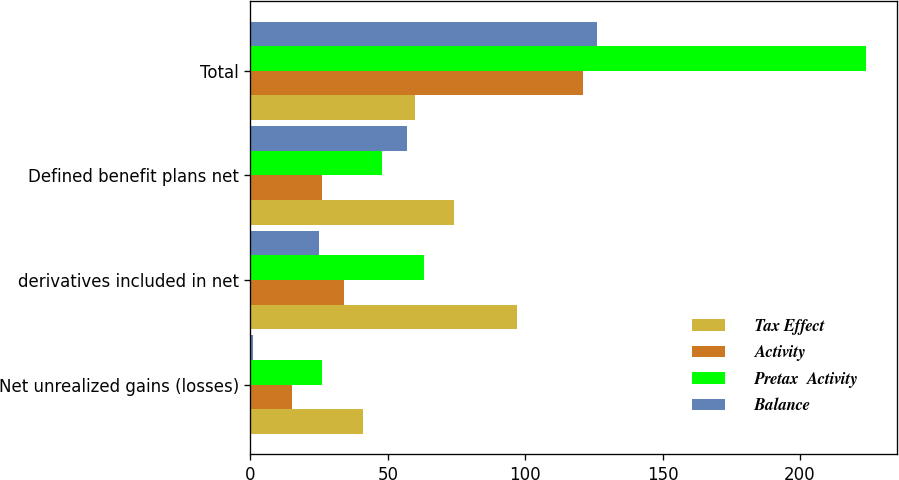<chart> <loc_0><loc_0><loc_500><loc_500><stacked_bar_chart><ecel><fcel>Net unrealized gains (losses)<fcel>derivatives included in net<fcel>Defined benefit plans net<fcel>Total<nl><fcel>Tax Effect<fcel>41<fcel>97<fcel>74<fcel>60<nl><fcel>Activity<fcel>15<fcel>34<fcel>26<fcel>121<nl><fcel>Pretax  Activity<fcel>26<fcel>63<fcel>48<fcel>224<nl><fcel>Balance<fcel>1<fcel>25<fcel>57<fcel>126<nl></chart> 